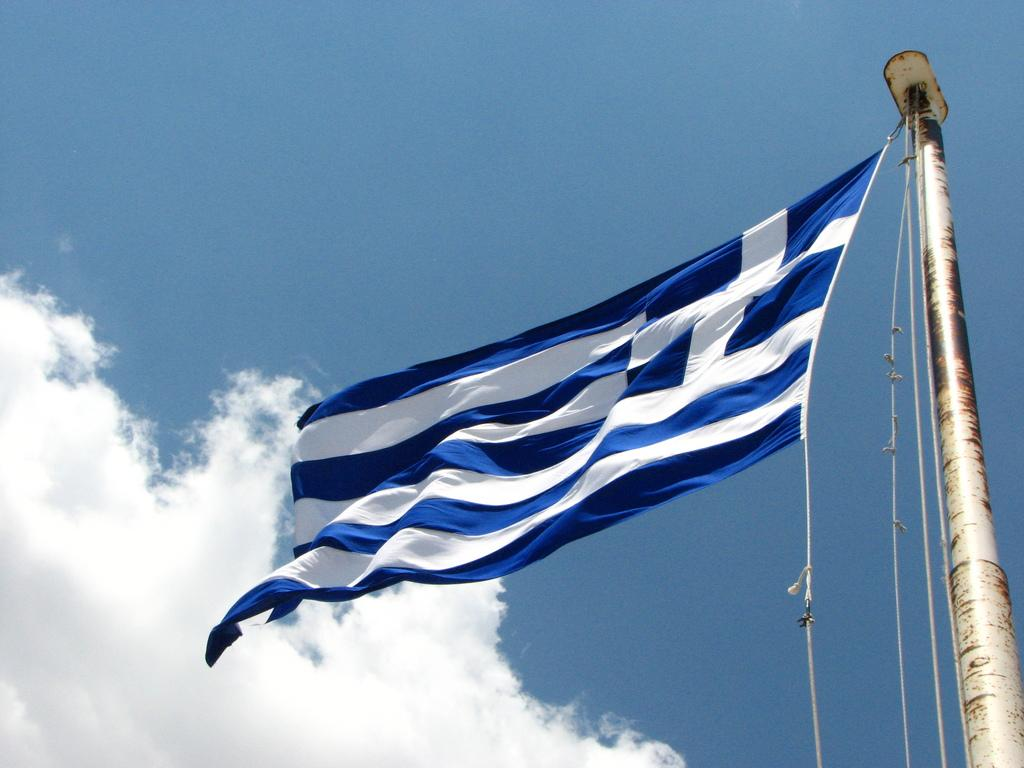What is the main object in the image? There is a flag in the image. How is the flag supported? The flag is on a pole. What colors are used on the flag? The flag is in white and blue colors. What can be seen in the background of the image? There are clouds and a blue sky in the background of the image. Can you see a cat playing with corn in the sink in the image? No, there is no cat, corn, or sink present in the image. 